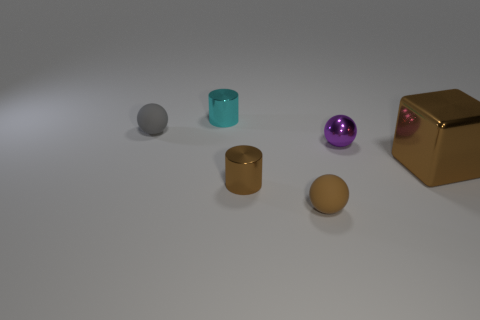Is there anything else that has the same size as the brown shiny block?
Make the answer very short. No. How many other things are the same size as the purple object?
Ensure brevity in your answer.  4. There is a large shiny cube; is its color the same as the cylinder that is behind the large brown metallic thing?
Give a very brief answer. No. What number of objects are either big green cubes or tiny brown metallic objects?
Your answer should be compact. 1. Are there any other things that are the same color as the large metal thing?
Your answer should be compact. Yes. Do the cyan thing and the ball on the right side of the tiny brown matte ball have the same material?
Keep it short and to the point. Yes. The small matte thing behind the small matte sphere in front of the small brown cylinder is what shape?
Offer a very short reply. Sphere. What shape is the metallic object that is both to the left of the brown metal block and to the right of the small brown rubber thing?
Provide a succinct answer. Sphere. What number of objects are either small gray rubber objects or things that are behind the large object?
Provide a succinct answer. 3. There is a small brown thing that is the same shape as the gray object; what material is it?
Your response must be concise. Rubber. 